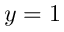Convert formula to latex. <formula><loc_0><loc_0><loc_500><loc_500>y = 1</formula> 